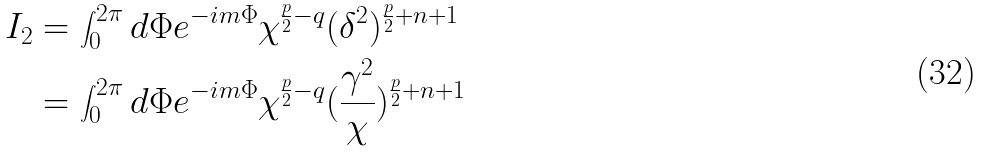Convert formula to latex. <formula><loc_0><loc_0><loc_500><loc_500>I _ { 2 } & = \int _ { 0 } ^ { 2 \pi } d \Phi e ^ { - i m \Phi } \chi ^ { \frac { p } { 2 } - q } ( \delta ^ { 2 } ) ^ { \frac { p } { 2 } + n + 1 } \\ & = \int _ { 0 } ^ { 2 \pi } d \Phi e ^ { - i m \Phi } \chi ^ { \frac { p } { 2 } - q } ( \frac { \gamma ^ { 2 } } { \chi } ) ^ { \frac { p } { 2 } + n + 1 }</formula> 